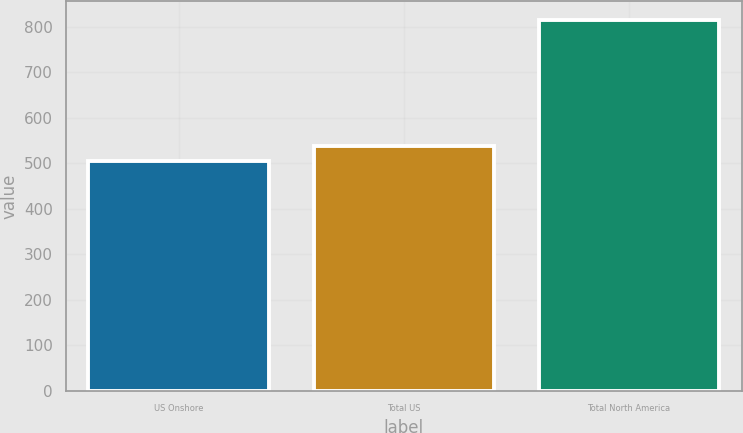Convert chart. <chart><loc_0><loc_0><loc_500><loc_500><bar_chart><fcel>US Onshore<fcel>Total US<fcel>Total North America<nl><fcel>506.5<fcel>537.37<fcel>815.2<nl></chart> 